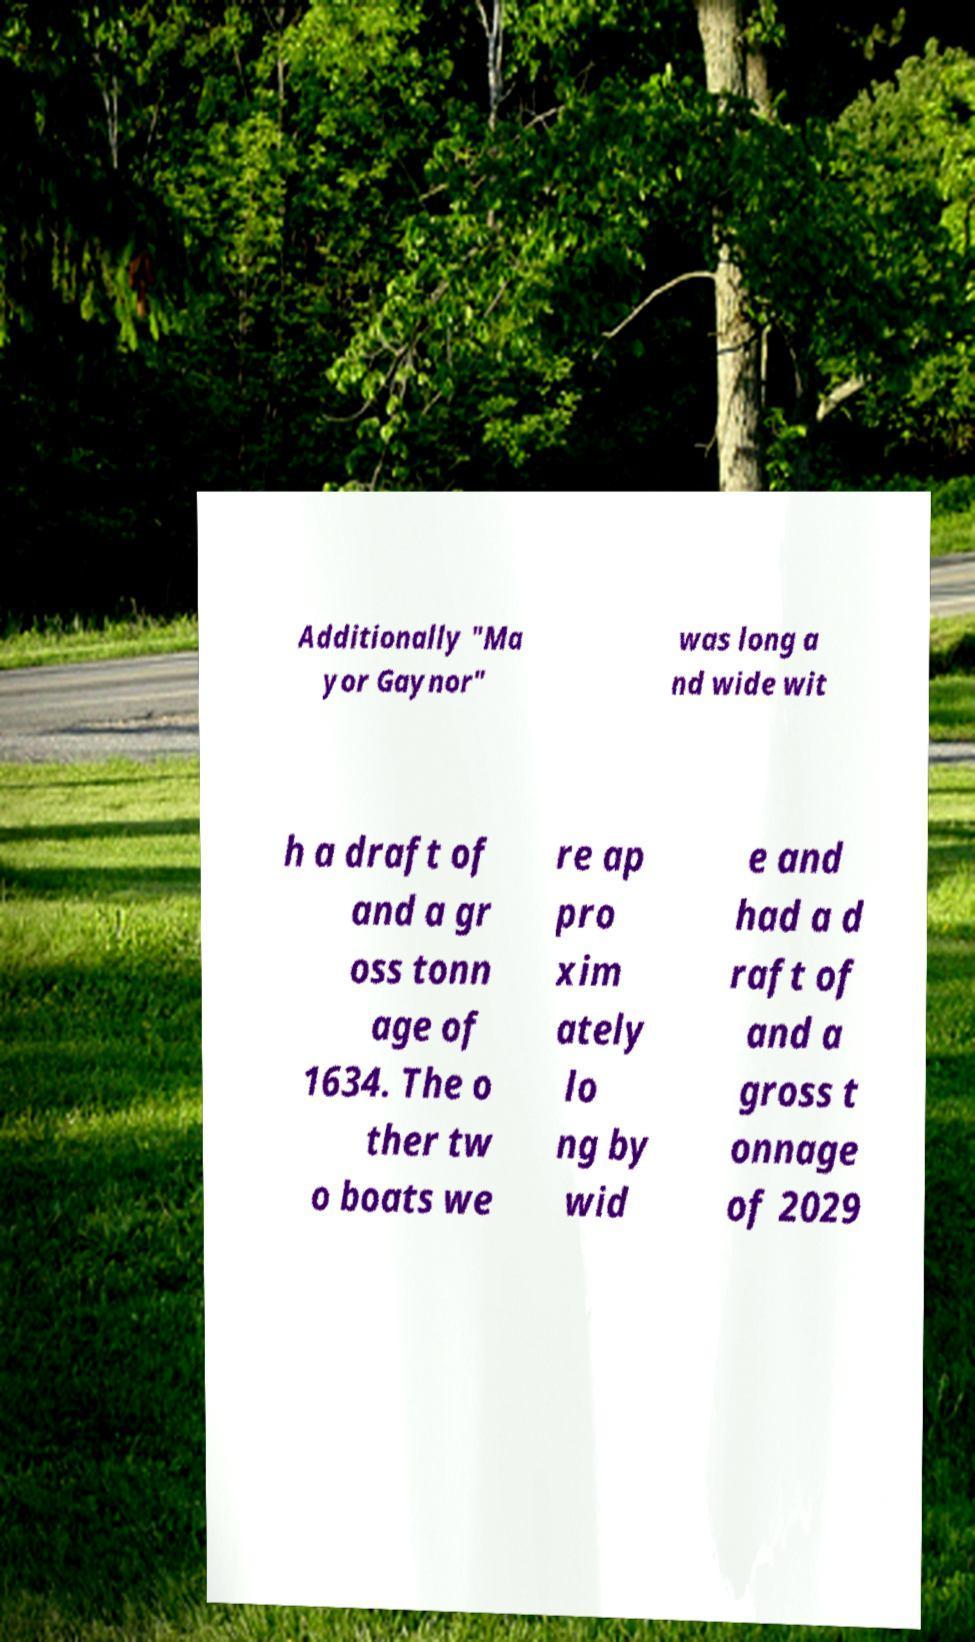There's text embedded in this image that I need extracted. Can you transcribe it verbatim? Additionally "Ma yor Gaynor" was long a nd wide wit h a draft of and a gr oss tonn age of 1634. The o ther tw o boats we re ap pro xim ately lo ng by wid e and had a d raft of and a gross t onnage of 2029 